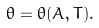<formula> <loc_0><loc_0><loc_500><loc_500>\theta = \theta ( A , T ) .</formula> 